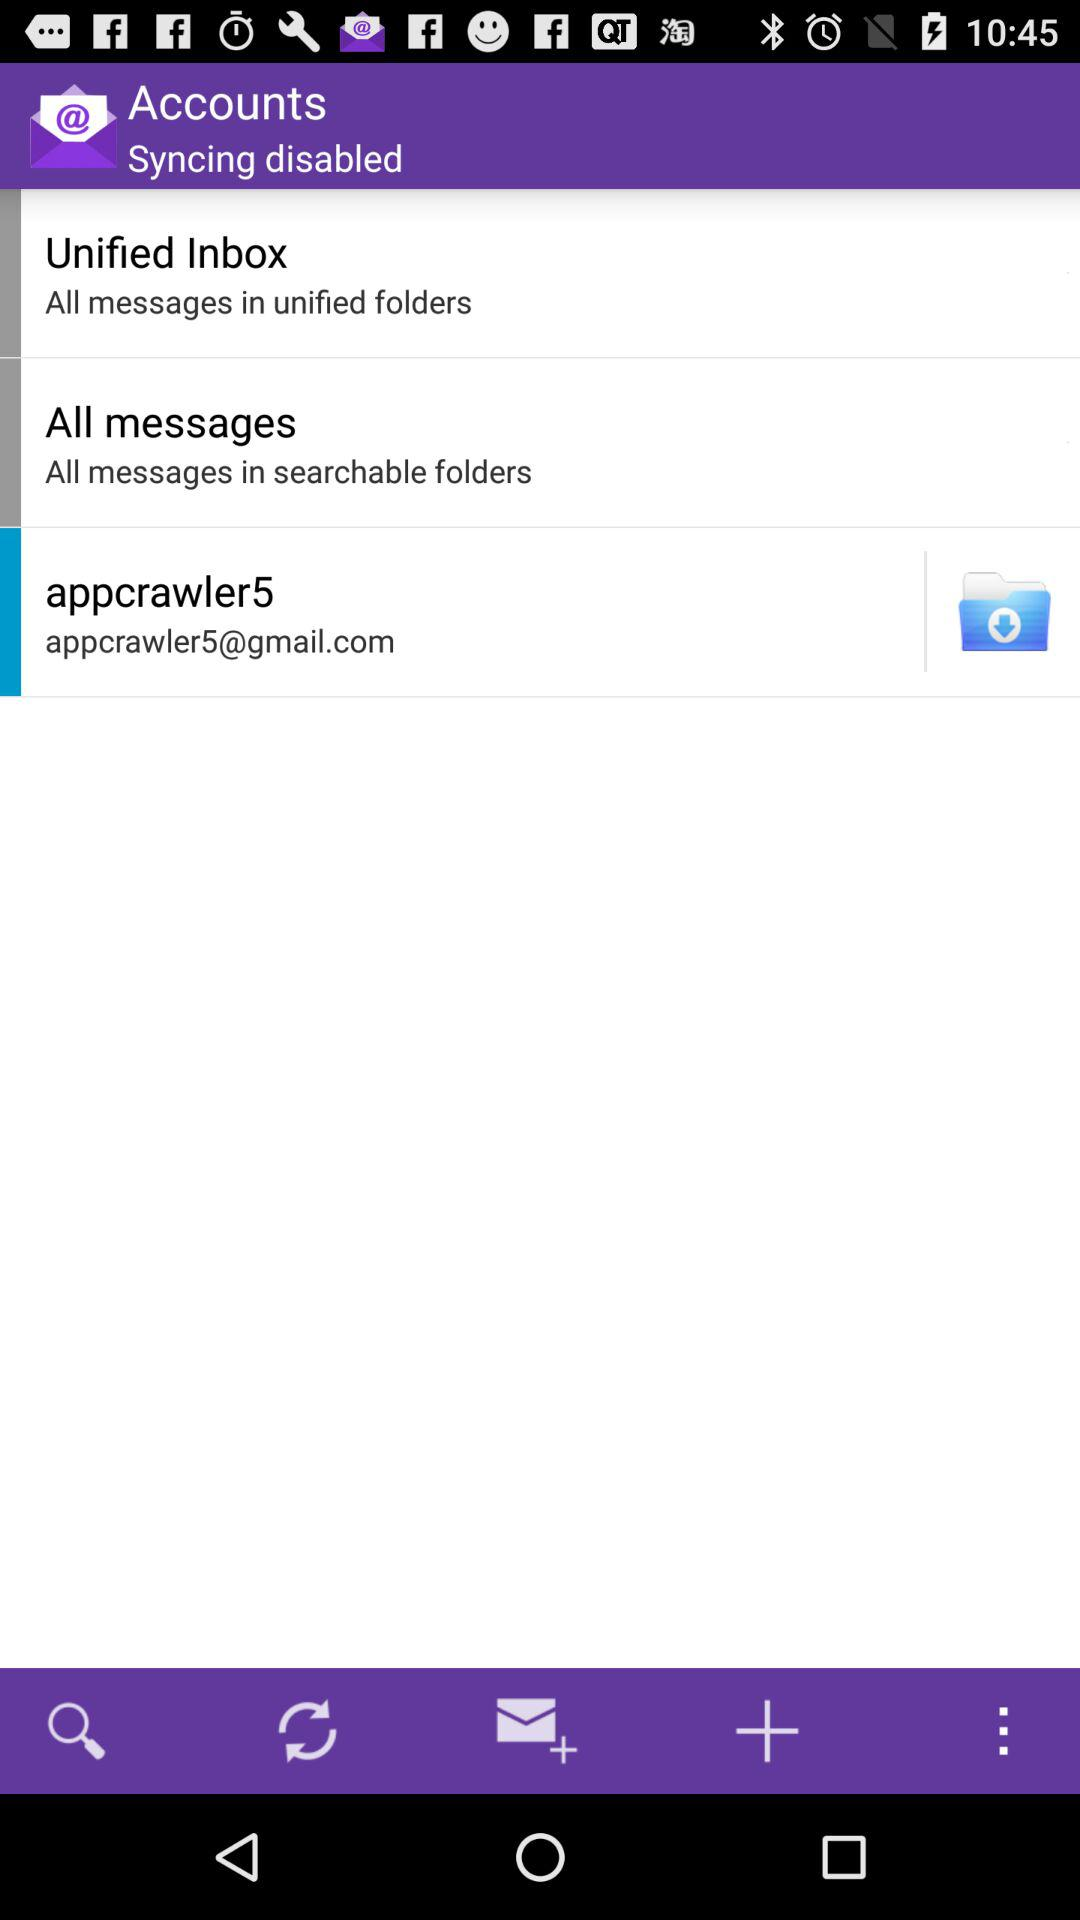How many total messages are there?
When the provided information is insufficient, respond with <no answer>. <no answer> 